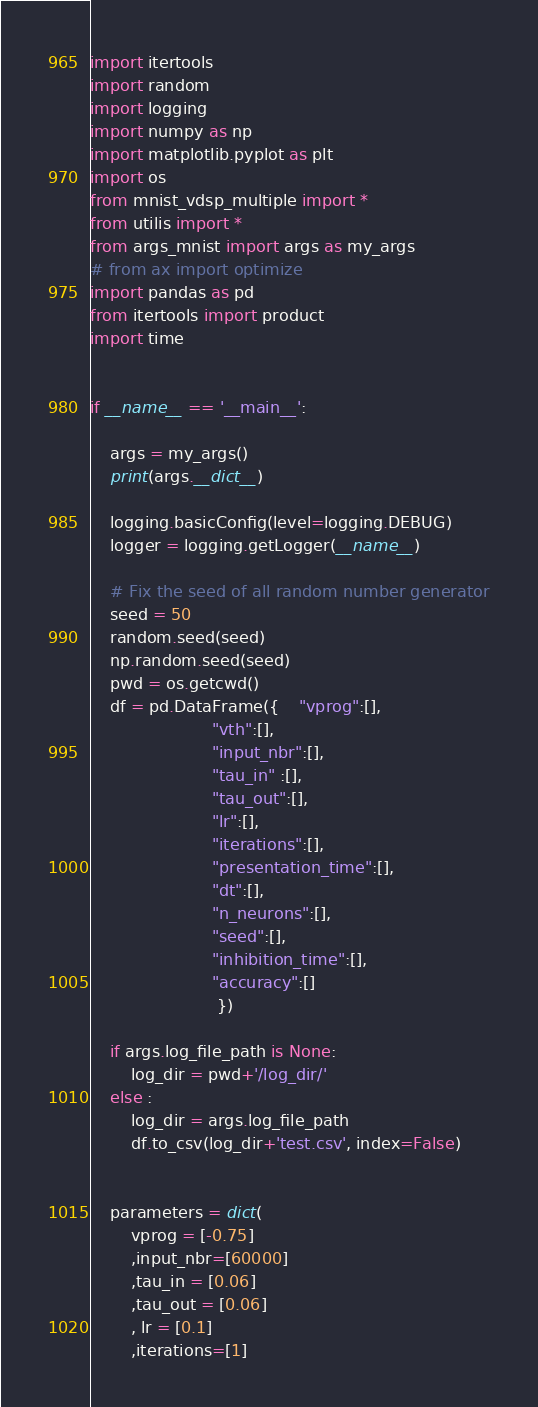<code> <loc_0><loc_0><loc_500><loc_500><_Python_>
import itertools
import random
import logging
import numpy as np
import matplotlib.pyplot as plt
import os
from mnist_vdsp_multiple import *
from utilis import *
from args_mnist import args as my_args
# from ax import optimize
import pandas as pd
from itertools import product
import time


if __name__ == '__main__':

	args = my_args()
	print(args.__dict__)

	logging.basicConfig(level=logging.DEBUG)
	logger = logging.getLogger(__name__)

	# Fix the seed of all random number generator
	seed = 50
	random.seed(seed)
	np.random.seed(seed)
	pwd = os.getcwd()
	df = pd.DataFrame({	"vprog":[],
						"vth":[],
						"input_nbr":[],
						"tau_in" :[],
						"tau_out":[],
                        "lr":[],
                        "iterations":[],
                        "presentation_time":[],
                        "dt":[],
                        "n_neurons":[],
                        "seed":[],
                        "inhibition_time":[],
                        "accuracy":[]
                         })

	if args.log_file_path is None:
		log_dir = pwd+'/log_dir/'
	else : 
		log_dir = args.log_file_path
		df.to_csv(log_dir+'test.csv', index=False)


	parameters = dict(
		vprog = [-0.75]
		,input_nbr=[60000]
		,tau_in = [0.06]
		,tau_out = [0.06]
		, lr = [0.1]
		,iterations=[1]</code> 